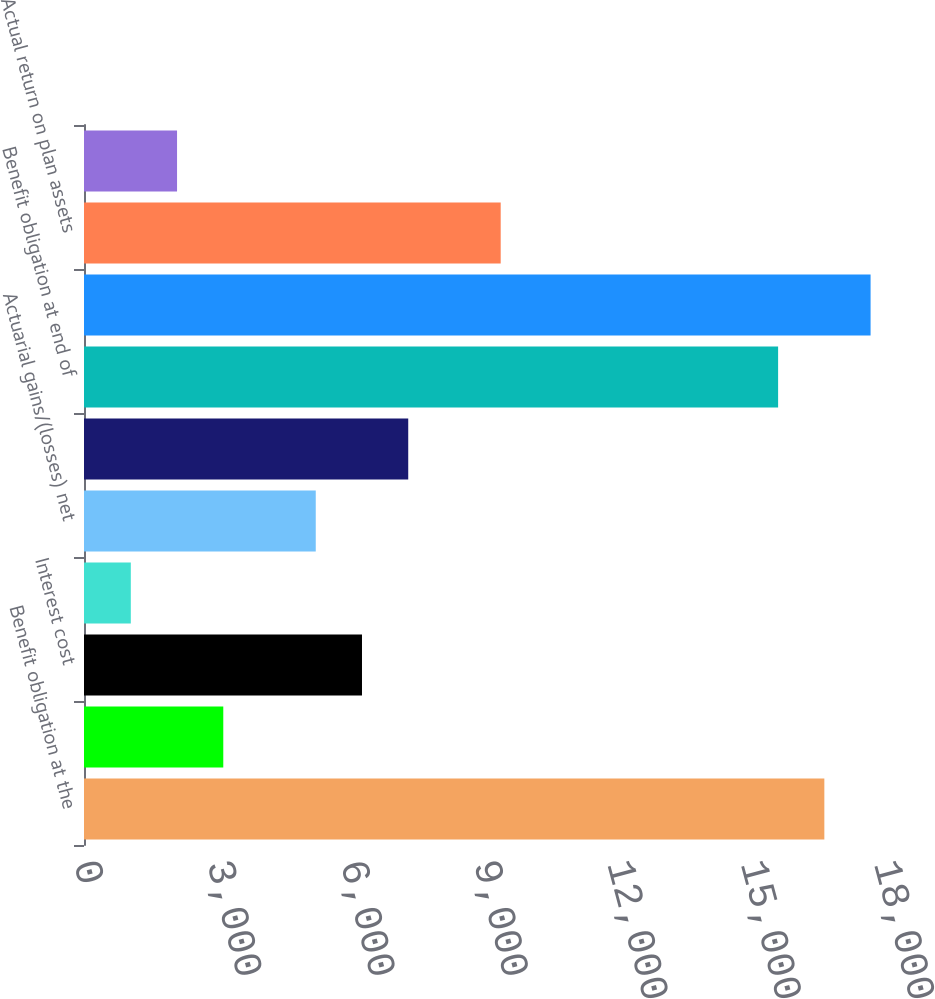Convert chart to OTSL. <chart><loc_0><loc_0><loc_500><loc_500><bar_chart><fcel>Benefit obligation at the<fcel>Service cost<fcel>Interest cost<fcel>Amendments<fcel>Actuarial gains/(losses) net<fcel>Benefits paid<fcel>Benefit obligation at end of<fcel>Fair value of plan assets at<fcel>Actual return on plan assets<fcel>Employer contributions<nl><fcel>16657.8<fcel>3133.9<fcel>6254.8<fcel>1053.3<fcel>5214.5<fcel>7295.1<fcel>15617.5<fcel>17698.1<fcel>9375.7<fcel>2093.6<nl></chart> 